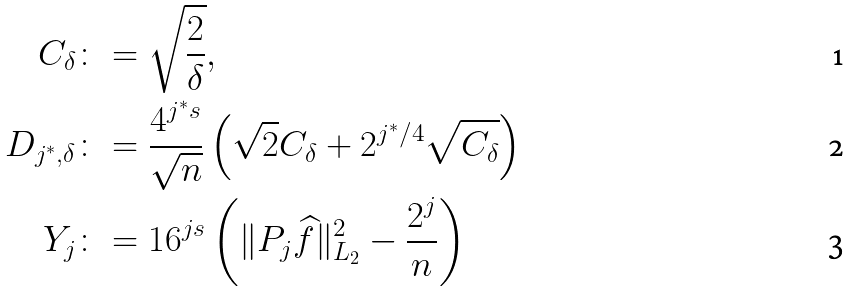<formula> <loc_0><loc_0><loc_500><loc_500>C _ { \delta } & \colon = \sqrt { \frac { 2 } { \delta } } , \\ D _ { j ^ { \ast } , \delta } & \colon = \frac { 4 ^ { j ^ { \ast } s } } { \sqrt { n } } \left ( \sqrt { 2 } C _ { \delta } + 2 ^ { j ^ { \ast } / 4 } \sqrt { C _ { \delta } } \right ) \\ Y _ { j } & \colon = 1 6 ^ { j s } \left ( \| P _ { j } \widehat { f } \| _ { L _ { 2 } } ^ { 2 } - \frac { 2 ^ { j } } { n } \right )</formula> 